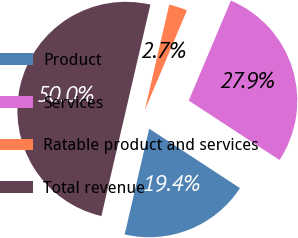<chart> <loc_0><loc_0><loc_500><loc_500><pie_chart><fcel>Product<fcel>Services<fcel>Ratable product and services<fcel>Total revenue<nl><fcel>19.4%<fcel>27.87%<fcel>2.73%<fcel>50.0%<nl></chart> 